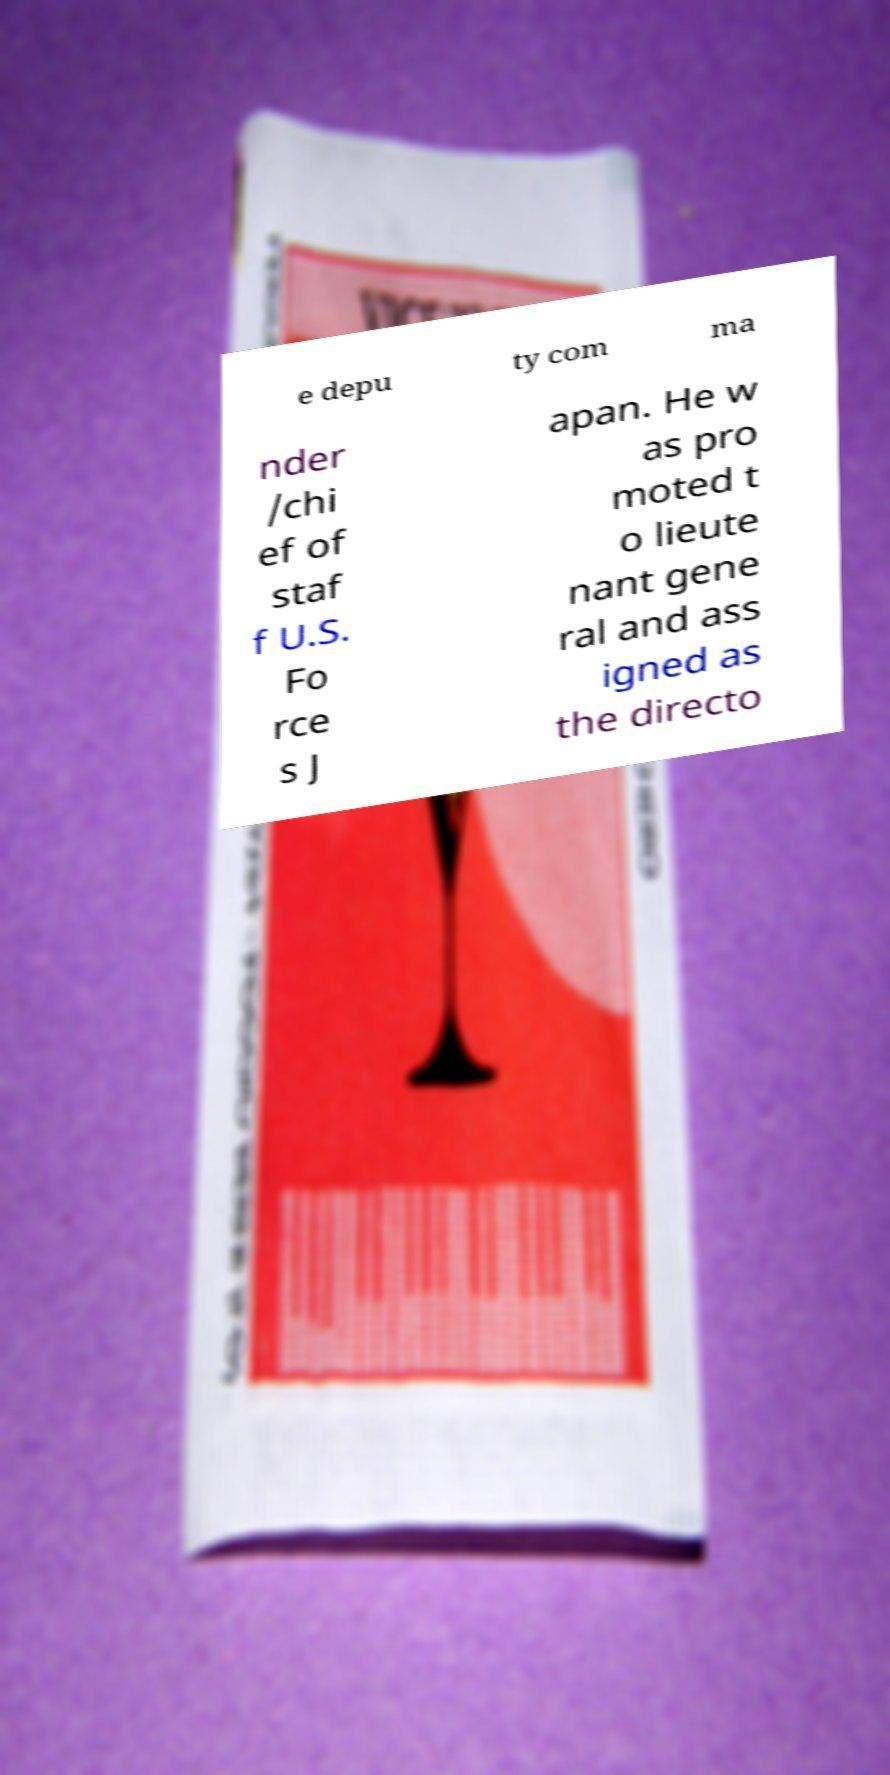Can you read and provide the text displayed in the image?This photo seems to have some interesting text. Can you extract and type it out for me? e depu ty com ma nder /chi ef of staf f U.S. Fo rce s J apan. He w as pro moted t o lieute nant gene ral and ass igned as the directo 